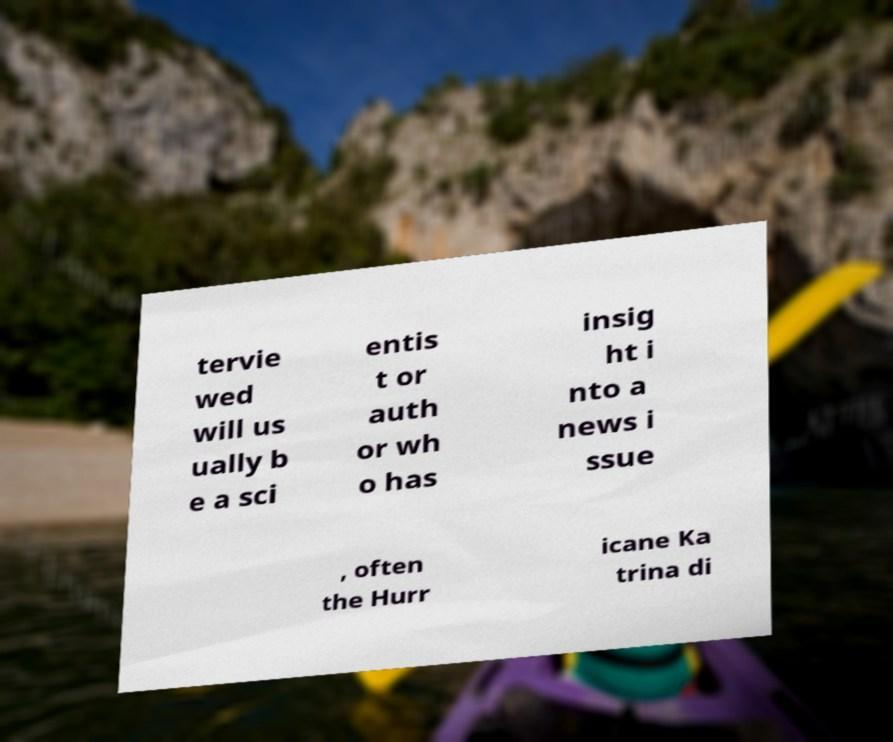What messages or text are displayed in this image? I need them in a readable, typed format. tervie wed will us ually b e a sci entis t or auth or wh o has insig ht i nto a news i ssue , often the Hurr icane Ka trina di 